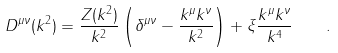<formula> <loc_0><loc_0><loc_500><loc_500>D ^ { \mu \nu } ( k ^ { 2 } ) = \frac { Z ( k ^ { 2 } ) } { k ^ { 2 } } \left ( \delta ^ { \mu \nu } - \frac { k ^ { \mu } k ^ { \nu } } { k ^ { 2 } } \right ) + \xi \frac { k ^ { \mu } k ^ { \nu } } { k ^ { 4 } } \quad .</formula> 